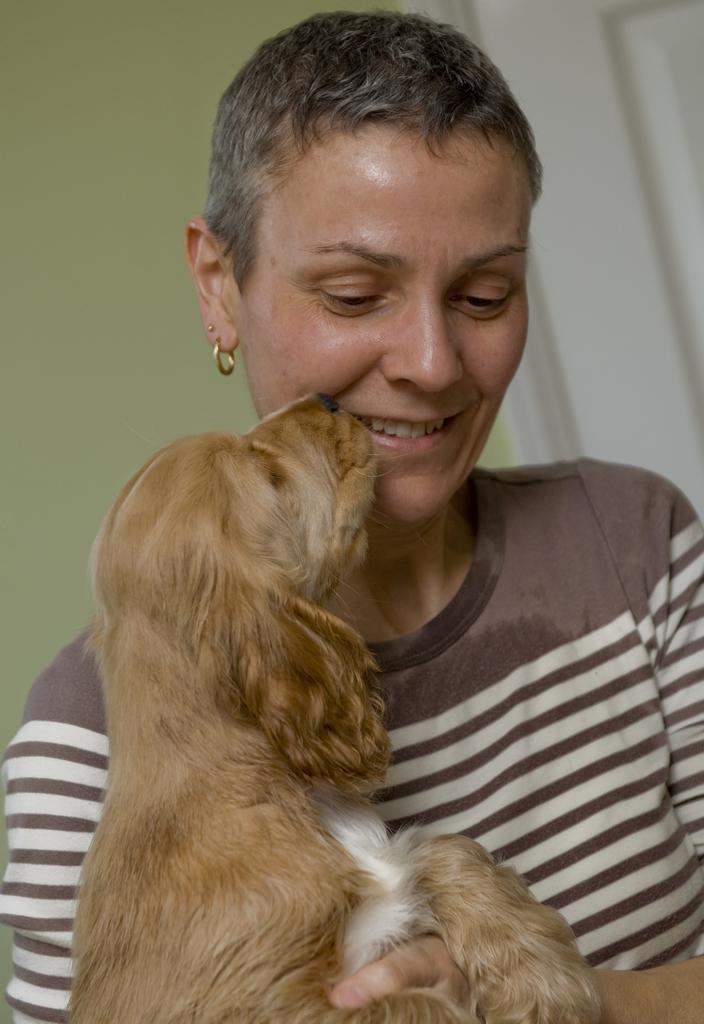Who is in the image? There is a woman in the image. What is the woman holding? The woman is holding a dog. Can you describe the dog's appearance? The dog is brown and white in color. What can be seen in the background of the image? There is a wall in the background of the image. What color is the wall? The wall is cream in color. What architectural feature is visible in the image? There is a door visible in the image. How does the woman maintain her balance while performing an exchange with the foot of the dog in the image? There is no exchange or foot of the dog present in the image; the woman is simply holding the dog. 